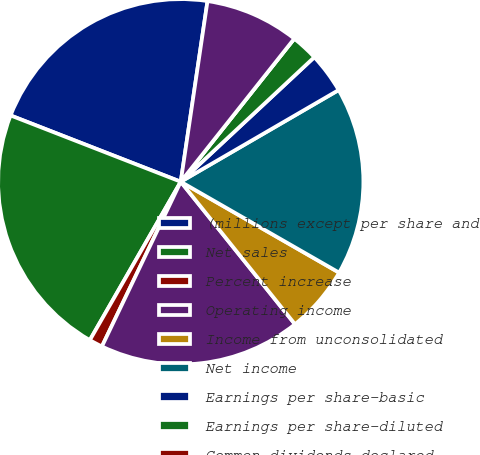Convert chart to OTSL. <chart><loc_0><loc_0><loc_500><loc_500><pie_chart><fcel>(millions except per share and<fcel>Net sales<fcel>Percent increase<fcel>Operating income<fcel>Income from unconsolidated<fcel>Net income<fcel>Earnings per share-basic<fcel>Earnings per share-diluted<fcel>Common dividends declared<fcel>Closing price non-voting<nl><fcel>21.42%<fcel>22.61%<fcel>1.19%<fcel>17.85%<fcel>5.95%<fcel>16.66%<fcel>3.57%<fcel>2.38%<fcel>0.0%<fcel>8.33%<nl></chart> 